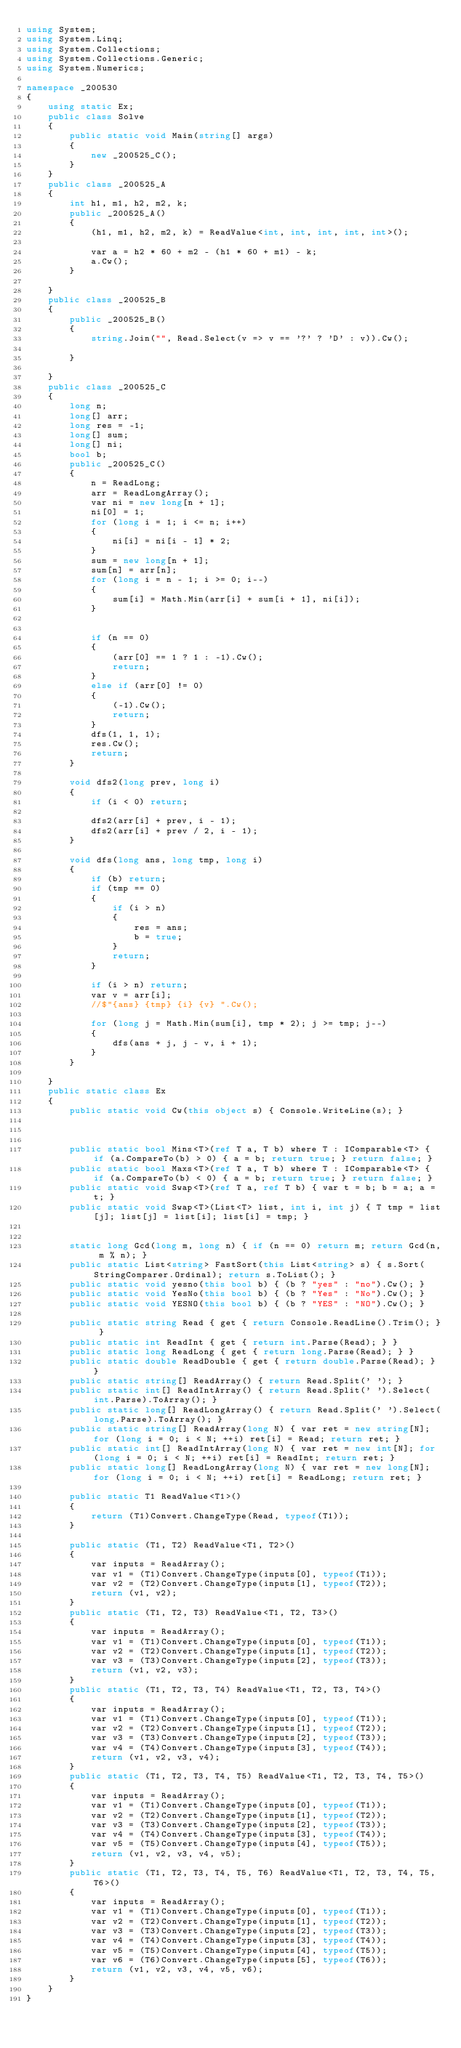Convert code to text. <code><loc_0><loc_0><loc_500><loc_500><_C#_>using System;
using System.Linq;
using System.Collections;
using System.Collections.Generic;
using System.Numerics;

namespace _200530
{
    using static Ex;
    public class Solve
    {
        public static void Main(string[] args)
        {
            new _200525_C();
        }
    }
    public class _200525_A
    {
        int h1, m1, h2, m2, k;
        public _200525_A()
        {
            (h1, m1, h2, m2, k) = ReadValue<int, int, int, int, int>();

            var a = h2 * 60 + m2 - (h1 * 60 + m1) - k;
            a.Cw();
        }

    }
    public class _200525_B
    {
        public _200525_B()
        {
            string.Join("", Read.Select(v => v == '?' ? 'D' : v)).Cw();

        }

    }
    public class _200525_C
    {
        long n;
        long[] arr;
        long res = -1;
        long[] sum;
        long[] ni;
        bool b;
        public _200525_C()
        {
            n = ReadLong;
            arr = ReadLongArray();
            var ni = new long[n + 1];
            ni[0] = 1;
            for (long i = 1; i <= n; i++)
            {
                ni[i] = ni[i - 1] * 2;
            }
            sum = new long[n + 1];
            sum[n] = arr[n];
            for (long i = n - 1; i >= 0; i--)
            {
                sum[i] = Math.Min(arr[i] + sum[i + 1], ni[i]);
            }


            if (n == 0)
            {
                (arr[0] == 1 ? 1 : -1).Cw();
                return;
            }
            else if (arr[0] != 0)
            {
                (-1).Cw();
                return;
            }
            dfs(1, 1, 1);
            res.Cw();
            return;
        }

        void dfs2(long prev, long i)
        {
            if (i < 0) return;

            dfs2(arr[i] + prev, i - 1);
            dfs2(arr[i] + prev / 2, i - 1);
        }

        void dfs(long ans, long tmp, long i)
        {
            if (b) return;
            if (tmp == 0)
            {
                if (i > n)
                {
                    res = ans;
                    b = true;
                }
                return;
            }

            if (i > n) return;
            var v = arr[i];
            //$"{ans} {tmp} {i} {v} ".Cw();

            for (long j = Math.Min(sum[i], tmp * 2); j >= tmp; j--)
            {
                dfs(ans + j, j - v, i + 1);
            }
        }

    }
    public static class Ex
    {
        public static void Cw(this object s) { Console.WriteLine(s); }



        public static bool Mins<T>(ref T a, T b) where T : IComparable<T> { if (a.CompareTo(b) > 0) { a = b; return true; } return false; }
        public static bool Maxs<T>(ref T a, T b) where T : IComparable<T> { if (a.CompareTo(b) < 0) { a = b; return true; } return false; }
        public static void Swap<T>(ref T a, ref T b) { var t = b; b = a; a = t; }
        public static void Swap<T>(List<T> list, int i, int j) { T tmp = list[j]; list[j] = list[i]; list[i] = tmp; }


        static long Gcd(long m, long n) { if (n == 0) return m; return Gcd(n, m % n); }
        public static List<string> FastSort(this List<string> s) { s.Sort(StringComparer.Ordinal); return s.ToList(); }
        public static void yesno(this bool b) { (b ? "yes" : "no").Cw(); }
        public static void YesNo(this bool b) { (b ? "Yes" : "No").Cw(); }
        public static void YESNO(this bool b) { (b ? "YES" : "NO").Cw(); }

        public static string Read { get { return Console.ReadLine().Trim(); } }
        public static int ReadInt { get { return int.Parse(Read); } }
        public static long ReadLong { get { return long.Parse(Read); } }
        public static double ReadDouble { get { return double.Parse(Read); } }
        public static string[] ReadArray() { return Read.Split(' '); }
        public static int[] ReadIntArray() { return Read.Split(' ').Select(int.Parse).ToArray(); }
        public static long[] ReadLongArray() { return Read.Split(' ').Select(long.Parse).ToArray(); }
        public static string[] ReadArray(long N) { var ret = new string[N]; for (long i = 0; i < N; ++i) ret[i] = Read; return ret; }
        public static int[] ReadIntArray(long N) { var ret = new int[N]; for (long i = 0; i < N; ++i) ret[i] = ReadInt; return ret; }
        public static long[] ReadLongArray(long N) { var ret = new long[N]; for (long i = 0; i < N; ++i) ret[i] = ReadLong; return ret; }

        public static T1 ReadValue<T1>()
        {
            return (T1)Convert.ChangeType(Read, typeof(T1));
        }

        public static (T1, T2) ReadValue<T1, T2>()
        {
            var inputs = ReadArray();
            var v1 = (T1)Convert.ChangeType(inputs[0], typeof(T1));
            var v2 = (T2)Convert.ChangeType(inputs[1], typeof(T2));
            return (v1, v2);
        }
        public static (T1, T2, T3) ReadValue<T1, T2, T3>()
        {
            var inputs = ReadArray();
            var v1 = (T1)Convert.ChangeType(inputs[0], typeof(T1));
            var v2 = (T2)Convert.ChangeType(inputs[1], typeof(T2));
            var v3 = (T3)Convert.ChangeType(inputs[2], typeof(T3));
            return (v1, v2, v3);
        }
        public static (T1, T2, T3, T4) ReadValue<T1, T2, T3, T4>()
        {
            var inputs = ReadArray();
            var v1 = (T1)Convert.ChangeType(inputs[0], typeof(T1));
            var v2 = (T2)Convert.ChangeType(inputs[1], typeof(T2));
            var v3 = (T3)Convert.ChangeType(inputs[2], typeof(T3));
            var v4 = (T4)Convert.ChangeType(inputs[3], typeof(T4));
            return (v1, v2, v3, v4);
        }
        public static (T1, T2, T3, T4, T5) ReadValue<T1, T2, T3, T4, T5>()
        {
            var inputs = ReadArray();
            var v1 = (T1)Convert.ChangeType(inputs[0], typeof(T1));
            var v2 = (T2)Convert.ChangeType(inputs[1], typeof(T2));
            var v3 = (T3)Convert.ChangeType(inputs[2], typeof(T3));
            var v4 = (T4)Convert.ChangeType(inputs[3], typeof(T4));
            var v5 = (T5)Convert.ChangeType(inputs[4], typeof(T5));
            return (v1, v2, v3, v4, v5);
        }
        public static (T1, T2, T3, T4, T5, T6) ReadValue<T1, T2, T3, T4, T5, T6>()
        {
            var inputs = ReadArray();
            var v1 = (T1)Convert.ChangeType(inputs[0], typeof(T1));
            var v2 = (T2)Convert.ChangeType(inputs[1], typeof(T2));
            var v3 = (T3)Convert.ChangeType(inputs[2], typeof(T3));
            var v4 = (T4)Convert.ChangeType(inputs[3], typeof(T4));
            var v5 = (T5)Convert.ChangeType(inputs[4], typeof(T5));
            var v6 = (T6)Convert.ChangeType(inputs[5], typeof(T6));
            return (v1, v2, v3, v4, v5, v6);
        }
    }
}
</code> 